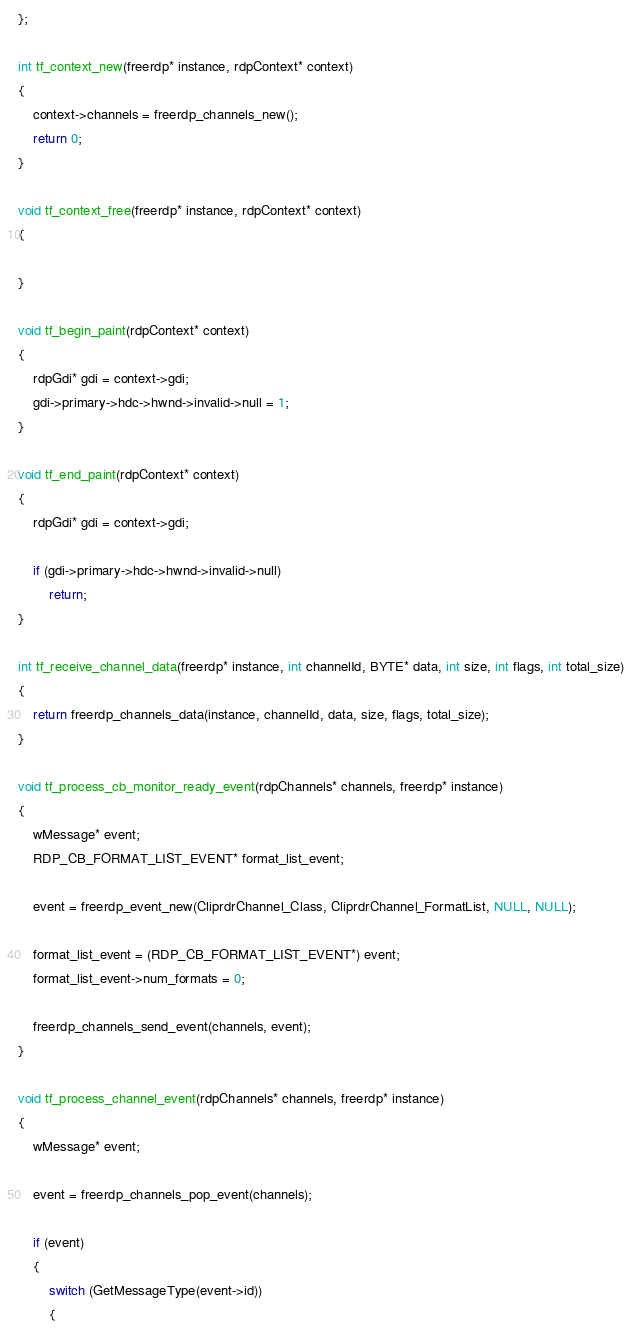Convert code to text. <code><loc_0><loc_0><loc_500><loc_500><_C_>};

int tf_context_new(freerdp* instance, rdpContext* context)
{
	context->channels = freerdp_channels_new();
	return 0;
}

void tf_context_free(freerdp* instance, rdpContext* context)
{

}

void tf_begin_paint(rdpContext* context)
{
	rdpGdi* gdi = context->gdi;
	gdi->primary->hdc->hwnd->invalid->null = 1;
}

void tf_end_paint(rdpContext* context)
{
	rdpGdi* gdi = context->gdi;

	if (gdi->primary->hdc->hwnd->invalid->null)
		return;
}

int tf_receive_channel_data(freerdp* instance, int channelId, BYTE* data, int size, int flags, int total_size)
{
	return freerdp_channels_data(instance, channelId, data, size, flags, total_size);
}

void tf_process_cb_monitor_ready_event(rdpChannels* channels, freerdp* instance)
{
	wMessage* event;
	RDP_CB_FORMAT_LIST_EVENT* format_list_event;

	event = freerdp_event_new(CliprdrChannel_Class, CliprdrChannel_FormatList, NULL, NULL);

	format_list_event = (RDP_CB_FORMAT_LIST_EVENT*) event;
	format_list_event->num_formats = 0;

	freerdp_channels_send_event(channels, event);
}

void tf_process_channel_event(rdpChannels* channels, freerdp* instance)
{
	wMessage* event;

	event = freerdp_channels_pop_event(channels);

	if (event)
	{
		switch (GetMessageType(event->id))
		{</code> 